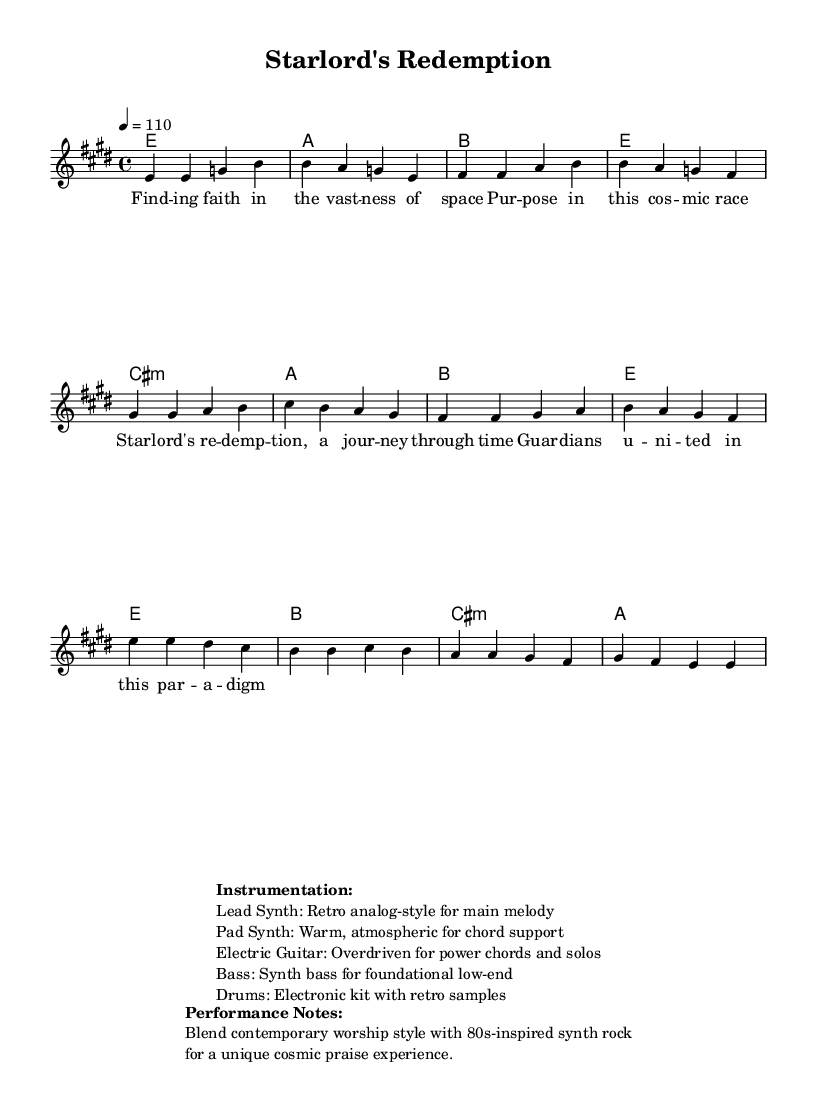What is the key signature of this music? The key signature is E major, which has four sharps: F sharp, C sharp, G sharp, and D sharp. These sharps are indicated before the notes in the key signature at the beginning of the sheet music.
Answer: E major What is the time signature of this song? The time signature is 4/4, which is indicated at the beginning of the music sheet. This means there are four beats in each measure and the quarter note receives one beat.
Answer: 4/4 What is the tempo marking of the piece? The tempo marking indicates that the piece should be played at a speed of 110 beats per minute, which is noted in the tempo line at the beginning of the score.
Answer: 110 How many bars are there in the chorus? The chorus consists of four bars, as noted by the dividing lines that separate the measures in that section of the sheet music.
Answer: Four What is the primary instrument used for the main melody? The lead synth is listed as the primary instrument for the main melody, as indicated in the instrumentation section of the sheet music.
Answer: Lead Synth What genre blend is suggested for this piece? The performance notes suggest blending contemporary worship style with 80s-inspired synth rock to create a unique cosmic praise experience, as emphasized in the performance notes section of the sheet music.
Answer: Contemporary worship with 80s synth rock What is the first lyric line of the song? The first lyric line is "Finding faith in the vastness of space," which matches the placement of the lyrics under the melody notes in the sheet music.
Answer: Finding faith in the vastness of space 